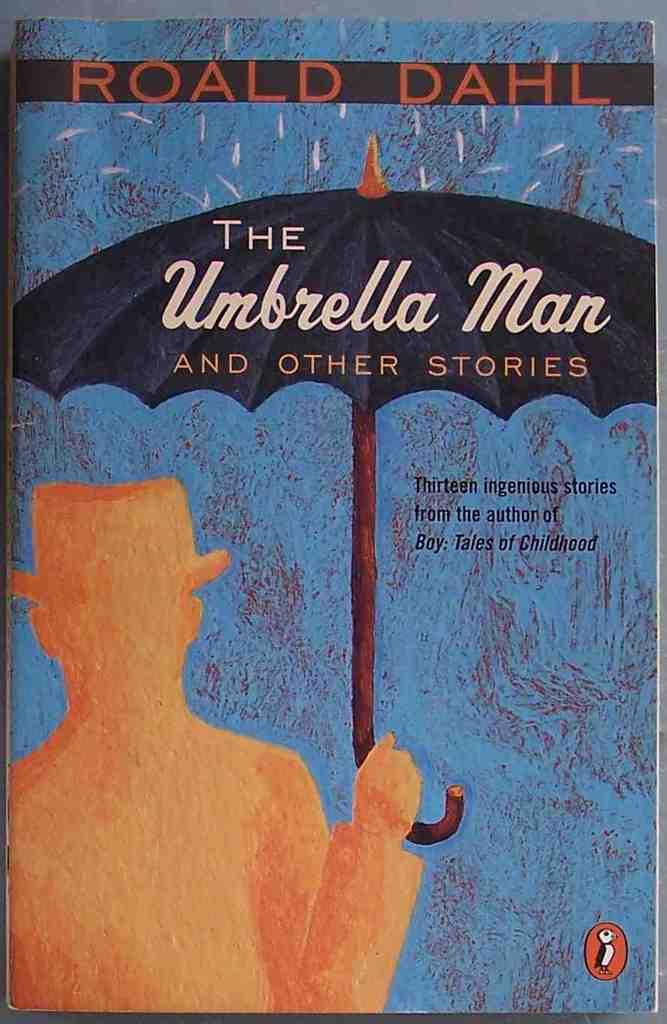How many stories are in this book?
Ensure brevity in your answer.  13. 